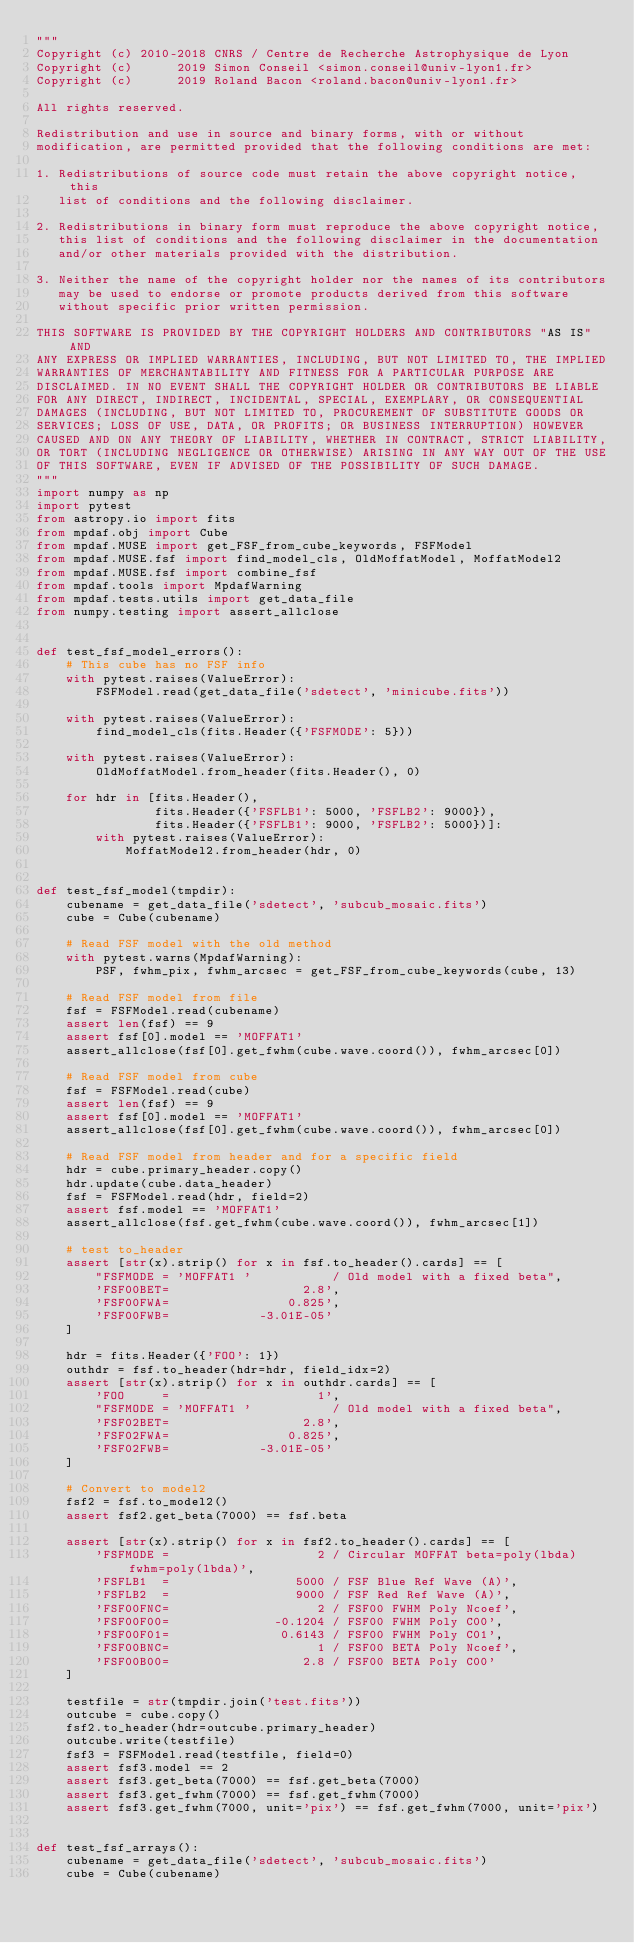<code> <loc_0><loc_0><loc_500><loc_500><_Python_>"""
Copyright (c) 2010-2018 CNRS / Centre de Recherche Astrophysique de Lyon
Copyright (c)      2019 Simon Conseil <simon.conseil@univ-lyon1.fr>
Copyright (c)      2019 Roland Bacon <roland.bacon@univ-lyon1.fr>

All rights reserved.

Redistribution and use in source and binary forms, with or without
modification, are permitted provided that the following conditions are met:

1. Redistributions of source code must retain the above copyright notice, this
   list of conditions and the following disclaimer.

2. Redistributions in binary form must reproduce the above copyright notice,
   this list of conditions and the following disclaimer in the documentation
   and/or other materials provided with the distribution.

3. Neither the name of the copyright holder nor the names of its contributors
   may be used to endorse or promote products derived from this software
   without specific prior written permission.

THIS SOFTWARE IS PROVIDED BY THE COPYRIGHT HOLDERS AND CONTRIBUTORS "AS IS" AND
ANY EXPRESS OR IMPLIED WARRANTIES, INCLUDING, BUT NOT LIMITED TO, THE IMPLIED
WARRANTIES OF MERCHANTABILITY AND FITNESS FOR A PARTICULAR PURPOSE ARE
DISCLAIMED. IN NO EVENT SHALL THE COPYRIGHT HOLDER OR CONTRIBUTORS BE LIABLE
FOR ANY DIRECT, INDIRECT, INCIDENTAL, SPECIAL, EXEMPLARY, OR CONSEQUENTIAL
DAMAGES (INCLUDING, BUT NOT LIMITED TO, PROCUREMENT OF SUBSTITUTE GOODS OR
SERVICES; LOSS OF USE, DATA, OR PROFITS; OR BUSINESS INTERRUPTION) HOWEVER
CAUSED AND ON ANY THEORY OF LIABILITY, WHETHER IN CONTRACT, STRICT LIABILITY,
OR TORT (INCLUDING NEGLIGENCE OR OTHERWISE) ARISING IN ANY WAY OUT OF THE USE
OF THIS SOFTWARE, EVEN IF ADVISED OF THE POSSIBILITY OF SUCH DAMAGE.
"""
import numpy as np
import pytest
from astropy.io import fits
from mpdaf.obj import Cube
from mpdaf.MUSE import get_FSF_from_cube_keywords, FSFModel
from mpdaf.MUSE.fsf import find_model_cls, OldMoffatModel, MoffatModel2
from mpdaf.MUSE.fsf import combine_fsf
from mpdaf.tools import MpdafWarning
from mpdaf.tests.utils import get_data_file
from numpy.testing import assert_allclose


def test_fsf_model_errors():
    # This cube has no FSF info
    with pytest.raises(ValueError):
        FSFModel.read(get_data_file('sdetect', 'minicube.fits'))

    with pytest.raises(ValueError):
        find_model_cls(fits.Header({'FSFMODE': 5}))

    with pytest.raises(ValueError):
        OldMoffatModel.from_header(fits.Header(), 0)

    for hdr in [fits.Header(),
                fits.Header({'FSFLB1': 5000, 'FSFLB2': 9000}),
                fits.Header({'FSFLB1': 9000, 'FSFLB2': 5000})]:
        with pytest.raises(ValueError):
            MoffatModel2.from_header(hdr, 0)


def test_fsf_model(tmpdir):
    cubename = get_data_file('sdetect', 'subcub_mosaic.fits')
    cube = Cube(cubename)

    # Read FSF model with the old method
    with pytest.warns(MpdafWarning):
        PSF, fwhm_pix, fwhm_arcsec = get_FSF_from_cube_keywords(cube, 13)

    # Read FSF model from file
    fsf = FSFModel.read(cubename)
    assert len(fsf) == 9
    assert fsf[0].model == 'MOFFAT1'
    assert_allclose(fsf[0].get_fwhm(cube.wave.coord()), fwhm_arcsec[0])

    # Read FSF model from cube
    fsf = FSFModel.read(cube)
    assert len(fsf) == 9
    assert fsf[0].model == 'MOFFAT1'
    assert_allclose(fsf[0].get_fwhm(cube.wave.coord()), fwhm_arcsec[0])

    # Read FSF model from header and for a specific field
    hdr = cube.primary_header.copy()
    hdr.update(cube.data_header)
    fsf = FSFModel.read(hdr, field=2)
    assert fsf.model == 'MOFFAT1'
    assert_allclose(fsf.get_fwhm(cube.wave.coord()), fwhm_arcsec[1])

    # test to_header
    assert [str(x).strip() for x in fsf.to_header().cards] == [
        "FSFMODE = 'MOFFAT1 '           / Old model with a fixed beta",
        'FSF00BET=                  2.8',
        'FSF00FWA=                0.825',
        'FSF00FWB=            -3.01E-05'
    ]

    hdr = fits.Header({'FOO': 1})
    outhdr = fsf.to_header(hdr=hdr, field_idx=2)
    assert [str(x).strip() for x in outhdr.cards] == [
        'FOO     =                    1',
        "FSFMODE = 'MOFFAT1 '           / Old model with a fixed beta",
        'FSF02BET=                  2.8',
        'FSF02FWA=                0.825',
        'FSF02FWB=            -3.01E-05'
    ]

    # Convert to model2
    fsf2 = fsf.to_model2()
    assert fsf2.get_beta(7000) == fsf.beta

    assert [str(x).strip() for x in fsf2.to_header().cards] == [
        'FSFMODE =                    2 / Circular MOFFAT beta=poly(lbda) fwhm=poly(lbda)',
        'FSFLB1  =                 5000 / FSF Blue Ref Wave (A)',
        'FSFLB2  =                 9000 / FSF Red Ref Wave (A)',
        'FSF00FNC=                    2 / FSF00 FWHM Poly Ncoef',
        'FSF00F00=              -0.1204 / FSF00 FWHM Poly C00',
        'FSF00F01=               0.6143 / FSF00 FWHM Poly C01',
        'FSF00BNC=                    1 / FSF00 BETA Poly Ncoef',
        'FSF00B00=                  2.8 / FSF00 BETA Poly C00'
    ]

    testfile = str(tmpdir.join('test.fits'))
    outcube = cube.copy()
    fsf2.to_header(hdr=outcube.primary_header)
    outcube.write(testfile)
    fsf3 = FSFModel.read(testfile, field=0)
    assert fsf3.model == 2
    assert fsf3.get_beta(7000) == fsf.get_beta(7000)
    assert fsf3.get_fwhm(7000) == fsf.get_fwhm(7000)
    assert fsf3.get_fwhm(7000, unit='pix') == fsf.get_fwhm(7000, unit='pix')


def test_fsf_arrays():
    cubename = get_data_file('sdetect', 'subcub_mosaic.fits')
    cube = Cube(cubename)</code> 